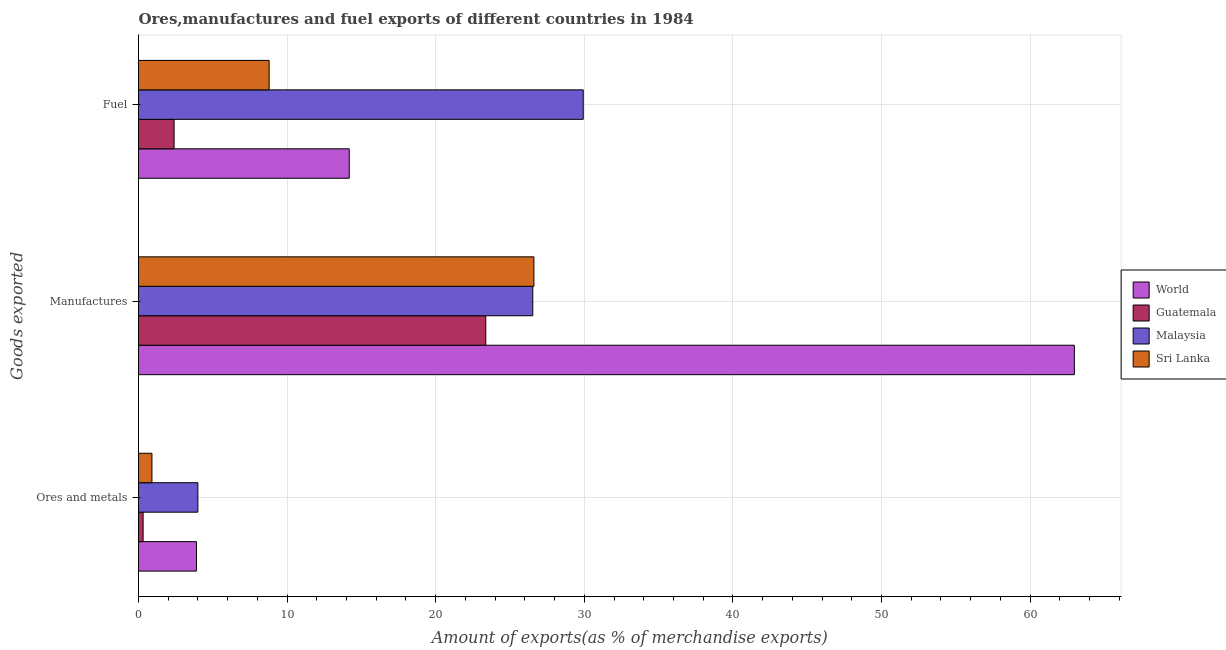How many different coloured bars are there?
Keep it short and to the point. 4. Are the number of bars per tick equal to the number of legend labels?
Your answer should be very brief. Yes. How many bars are there on the 2nd tick from the top?
Your answer should be very brief. 4. What is the label of the 2nd group of bars from the top?
Your answer should be compact. Manufactures. What is the percentage of manufactures exports in World?
Offer a very short reply. 62.98. Across all countries, what is the maximum percentage of fuel exports?
Keep it short and to the point. 29.93. Across all countries, what is the minimum percentage of manufactures exports?
Offer a terse response. 23.37. In which country was the percentage of ores and metals exports maximum?
Make the answer very short. Malaysia. In which country was the percentage of ores and metals exports minimum?
Give a very brief answer. Guatemala. What is the total percentage of ores and metals exports in the graph?
Provide a short and direct response. 9.11. What is the difference between the percentage of ores and metals exports in World and that in Malaysia?
Offer a terse response. -0.1. What is the difference between the percentage of ores and metals exports in Malaysia and the percentage of manufactures exports in Sri Lanka?
Your response must be concise. -22.62. What is the average percentage of ores and metals exports per country?
Ensure brevity in your answer.  2.28. What is the difference between the percentage of ores and metals exports and percentage of manufactures exports in World?
Keep it short and to the point. -59.08. What is the ratio of the percentage of ores and metals exports in Guatemala to that in World?
Provide a succinct answer. 0.08. What is the difference between the highest and the second highest percentage of fuel exports?
Make the answer very short. 15.75. What is the difference between the highest and the lowest percentage of manufactures exports?
Your answer should be compact. 39.61. What does the 1st bar from the top in Ores and metals represents?
Offer a terse response. Sri Lanka. What does the 1st bar from the bottom in Manufactures represents?
Your answer should be compact. World. Is it the case that in every country, the sum of the percentage of ores and metals exports and percentage of manufactures exports is greater than the percentage of fuel exports?
Ensure brevity in your answer.  Yes. Are all the bars in the graph horizontal?
Offer a very short reply. Yes. How many countries are there in the graph?
Provide a succinct answer. 4. Are the values on the major ticks of X-axis written in scientific E-notation?
Make the answer very short. No. How many legend labels are there?
Your response must be concise. 4. What is the title of the graph?
Offer a terse response. Ores,manufactures and fuel exports of different countries in 1984. What is the label or title of the X-axis?
Make the answer very short. Amount of exports(as % of merchandise exports). What is the label or title of the Y-axis?
Your response must be concise. Goods exported. What is the Amount of exports(as % of merchandise exports) of World in Ores and metals?
Offer a terse response. 3.9. What is the Amount of exports(as % of merchandise exports) of Guatemala in Ores and metals?
Make the answer very short. 0.31. What is the Amount of exports(as % of merchandise exports) of Malaysia in Ores and metals?
Offer a very short reply. 3.99. What is the Amount of exports(as % of merchandise exports) in Sri Lanka in Ores and metals?
Your answer should be very brief. 0.9. What is the Amount of exports(as % of merchandise exports) in World in Manufactures?
Keep it short and to the point. 62.98. What is the Amount of exports(as % of merchandise exports) in Guatemala in Manufactures?
Provide a succinct answer. 23.37. What is the Amount of exports(as % of merchandise exports) of Malaysia in Manufactures?
Provide a short and direct response. 26.53. What is the Amount of exports(as % of merchandise exports) in Sri Lanka in Manufactures?
Provide a short and direct response. 26.61. What is the Amount of exports(as % of merchandise exports) in World in Fuel?
Ensure brevity in your answer.  14.18. What is the Amount of exports(as % of merchandise exports) in Guatemala in Fuel?
Offer a very short reply. 2.39. What is the Amount of exports(as % of merchandise exports) in Malaysia in Fuel?
Provide a short and direct response. 29.93. What is the Amount of exports(as % of merchandise exports) of Sri Lanka in Fuel?
Offer a very short reply. 8.79. Across all Goods exported, what is the maximum Amount of exports(as % of merchandise exports) in World?
Give a very brief answer. 62.98. Across all Goods exported, what is the maximum Amount of exports(as % of merchandise exports) of Guatemala?
Your answer should be very brief. 23.37. Across all Goods exported, what is the maximum Amount of exports(as % of merchandise exports) in Malaysia?
Make the answer very short. 29.93. Across all Goods exported, what is the maximum Amount of exports(as % of merchandise exports) of Sri Lanka?
Your answer should be very brief. 26.61. Across all Goods exported, what is the minimum Amount of exports(as % of merchandise exports) in World?
Ensure brevity in your answer.  3.9. Across all Goods exported, what is the minimum Amount of exports(as % of merchandise exports) in Guatemala?
Offer a terse response. 0.31. Across all Goods exported, what is the minimum Amount of exports(as % of merchandise exports) in Malaysia?
Your answer should be compact. 3.99. Across all Goods exported, what is the minimum Amount of exports(as % of merchandise exports) of Sri Lanka?
Offer a terse response. 0.9. What is the total Amount of exports(as % of merchandise exports) of World in the graph?
Your response must be concise. 81.06. What is the total Amount of exports(as % of merchandise exports) in Guatemala in the graph?
Make the answer very short. 26.08. What is the total Amount of exports(as % of merchandise exports) of Malaysia in the graph?
Keep it short and to the point. 60.46. What is the total Amount of exports(as % of merchandise exports) of Sri Lanka in the graph?
Provide a short and direct response. 36.31. What is the difference between the Amount of exports(as % of merchandise exports) of World in Ores and metals and that in Manufactures?
Keep it short and to the point. -59.08. What is the difference between the Amount of exports(as % of merchandise exports) of Guatemala in Ores and metals and that in Manufactures?
Provide a succinct answer. -23.06. What is the difference between the Amount of exports(as % of merchandise exports) of Malaysia in Ores and metals and that in Manufactures?
Make the answer very short. -22.54. What is the difference between the Amount of exports(as % of merchandise exports) in Sri Lanka in Ores and metals and that in Manufactures?
Your answer should be compact. -25.71. What is the difference between the Amount of exports(as % of merchandise exports) of World in Ores and metals and that in Fuel?
Ensure brevity in your answer.  -10.28. What is the difference between the Amount of exports(as % of merchandise exports) in Guatemala in Ores and metals and that in Fuel?
Ensure brevity in your answer.  -2.09. What is the difference between the Amount of exports(as % of merchandise exports) of Malaysia in Ores and metals and that in Fuel?
Keep it short and to the point. -25.93. What is the difference between the Amount of exports(as % of merchandise exports) of Sri Lanka in Ores and metals and that in Fuel?
Provide a short and direct response. -7.89. What is the difference between the Amount of exports(as % of merchandise exports) of World in Manufactures and that in Fuel?
Ensure brevity in your answer.  48.8. What is the difference between the Amount of exports(as % of merchandise exports) of Guatemala in Manufactures and that in Fuel?
Offer a very short reply. 20.98. What is the difference between the Amount of exports(as % of merchandise exports) of Malaysia in Manufactures and that in Fuel?
Give a very brief answer. -3.4. What is the difference between the Amount of exports(as % of merchandise exports) of Sri Lanka in Manufactures and that in Fuel?
Give a very brief answer. 17.82. What is the difference between the Amount of exports(as % of merchandise exports) in World in Ores and metals and the Amount of exports(as % of merchandise exports) in Guatemala in Manufactures?
Your response must be concise. -19.47. What is the difference between the Amount of exports(as % of merchandise exports) in World in Ores and metals and the Amount of exports(as % of merchandise exports) in Malaysia in Manufactures?
Provide a succinct answer. -22.63. What is the difference between the Amount of exports(as % of merchandise exports) of World in Ores and metals and the Amount of exports(as % of merchandise exports) of Sri Lanka in Manufactures?
Make the answer very short. -22.71. What is the difference between the Amount of exports(as % of merchandise exports) of Guatemala in Ores and metals and the Amount of exports(as % of merchandise exports) of Malaysia in Manufactures?
Keep it short and to the point. -26.22. What is the difference between the Amount of exports(as % of merchandise exports) of Guatemala in Ores and metals and the Amount of exports(as % of merchandise exports) of Sri Lanka in Manufactures?
Provide a succinct answer. -26.3. What is the difference between the Amount of exports(as % of merchandise exports) of Malaysia in Ores and metals and the Amount of exports(as % of merchandise exports) of Sri Lanka in Manufactures?
Provide a short and direct response. -22.62. What is the difference between the Amount of exports(as % of merchandise exports) of World in Ores and metals and the Amount of exports(as % of merchandise exports) of Guatemala in Fuel?
Your answer should be compact. 1.5. What is the difference between the Amount of exports(as % of merchandise exports) in World in Ores and metals and the Amount of exports(as % of merchandise exports) in Malaysia in Fuel?
Make the answer very short. -26.03. What is the difference between the Amount of exports(as % of merchandise exports) in World in Ores and metals and the Amount of exports(as % of merchandise exports) in Sri Lanka in Fuel?
Give a very brief answer. -4.89. What is the difference between the Amount of exports(as % of merchandise exports) of Guatemala in Ores and metals and the Amount of exports(as % of merchandise exports) of Malaysia in Fuel?
Your answer should be very brief. -29.62. What is the difference between the Amount of exports(as % of merchandise exports) in Guatemala in Ores and metals and the Amount of exports(as % of merchandise exports) in Sri Lanka in Fuel?
Offer a very short reply. -8.48. What is the difference between the Amount of exports(as % of merchandise exports) of Malaysia in Ores and metals and the Amount of exports(as % of merchandise exports) of Sri Lanka in Fuel?
Give a very brief answer. -4.8. What is the difference between the Amount of exports(as % of merchandise exports) of World in Manufactures and the Amount of exports(as % of merchandise exports) of Guatemala in Fuel?
Your answer should be compact. 60.59. What is the difference between the Amount of exports(as % of merchandise exports) of World in Manufactures and the Amount of exports(as % of merchandise exports) of Malaysia in Fuel?
Ensure brevity in your answer.  33.05. What is the difference between the Amount of exports(as % of merchandise exports) in World in Manufactures and the Amount of exports(as % of merchandise exports) in Sri Lanka in Fuel?
Offer a very short reply. 54.19. What is the difference between the Amount of exports(as % of merchandise exports) in Guatemala in Manufactures and the Amount of exports(as % of merchandise exports) in Malaysia in Fuel?
Keep it short and to the point. -6.56. What is the difference between the Amount of exports(as % of merchandise exports) in Guatemala in Manufactures and the Amount of exports(as % of merchandise exports) in Sri Lanka in Fuel?
Offer a terse response. 14.58. What is the difference between the Amount of exports(as % of merchandise exports) of Malaysia in Manufactures and the Amount of exports(as % of merchandise exports) of Sri Lanka in Fuel?
Make the answer very short. 17.74. What is the average Amount of exports(as % of merchandise exports) in World per Goods exported?
Your answer should be compact. 27.02. What is the average Amount of exports(as % of merchandise exports) of Guatemala per Goods exported?
Make the answer very short. 8.69. What is the average Amount of exports(as % of merchandise exports) of Malaysia per Goods exported?
Ensure brevity in your answer.  20.15. What is the average Amount of exports(as % of merchandise exports) of Sri Lanka per Goods exported?
Provide a short and direct response. 12.1. What is the difference between the Amount of exports(as % of merchandise exports) of World and Amount of exports(as % of merchandise exports) of Guatemala in Ores and metals?
Ensure brevity in your answer.  3.59. What is the difference between the Amount of exports(as % of merchandise exports) in World and Amount of exports(as % of merchandise exports) in Malaysia in Ores and metals?
Your response must be concise. -0.1. What is the difference between the Amount of exports(as % of merchandise exports) of World and Amount of exports(as % of merchandise exports) of Sri Lanka in Ores and metals?
Your answer should be very brief. 3. What is the difference between the Amount of exports(as % of merchandise exports) in Guatemala and Amount of exports(as % of merchandise exports) in Malaysia in Ores and metals?
Give a very brief answer. -3.68. What is the difference between the Amount of exports(as % of merchandise exports) of Guatemala and Amount of exports(as % of merchandise exports) of Sri Lanka in Ores and metals?
Give a very brief answer. -0.59. What is the difference between the Amount of exports(as % of merchandise exports) in Malaysia and Amount of exports(as % of merchandise exports) in Sri Lanka in Ores and metals?
Offer a very short reply. 3.09. What is the difference between the Amount of exports(as % of merchandise exports) of World and Amount of exports(as % of merchandise exports) of Guatemala in Manufactures?
Offer a terse response. 39.61. What is the difference between the Amount of exports(as % of merchandise exports) in World and Amount of exports(as % of merchandise exports) in Malaysia in Manufactures?
Ensure brevity in your answer.  36.45. What is the difference between the Amount of exports(as % of merchandise exports) of World and Amount of exports(as % of merchandise exports) of Sri Lanka in Manufactures?
Your response must be concise. 36.37. What is the difference between the Amount of exports(as % of merchandise exports) in Guatemala and Amount of exports(as % of merchandise exports) in Malaysia in Manufactures?
Provide a short and direct response. -3.16. What is the difference between the Amount of exports(as % of merchandise exports) of Guatemala and Amount of exports(as % of merchandise exports) of Sri Lanka in Manufactures?
Offer a very short reply. -3.24. What is the difference between the Amount of exports(as % of merchandise exports) of Malaysia and Amount of exports(as % of merchandise exports) of Sri Lanka in Manufactures?
Provide a succinct answer. -0.08. What is the difference between the Amount of exports(as % of merchandise exports) of World and Amount of exports(as % of merchandise exports) of Guatemala in Fuel?
Offer a very short reply. 11.79. What is the difference between the Amount of exports(as % of merchandise exports) in World and Amount of exports(as % of merchandise exports) in Malaysia in Fuel?
Your response must be concise. -15.75. What is the difference between the Amount of exports(as % of merchandise exports) of World and Amount of exports(as % of merchandise exports) of Sri Lanka in Fuel?
Your answer should be very brief. 5.39. What is the difference between the Amount of exports(as % of merchandise exports) in Guatemala and Amount of exports(as % of merchandise exports) in Malaysia in Fuel?
Provide a succinct answer. -27.53. What is the difference between the Amount of exports(as % of merchandise exports) in Guatemala and Amount of exports(as % of merchandise exports) in Sri Lanka in Fuel?
Your answer should be very brief. -6.4. What is the difference between the Amount of exports(as % of merchandise exports) of Malaysia and Amount of exports(as % of merchandise exports) of Sri Lanka in Fuel?
Your answer should be compact. 21.14. What is the ratio of the Amount of exports(as % of merchandise exports) in World in Ores and metals to that in Manufactures?
Make the answer very short. 0.06. What is the ratio of the Amount of exports(as % of merchandise exports) of Guatemala in Ores and metals to that in Manufactures?
Make the answer very short. 0.01. What is the ratio of the Amount of exports(as % of merchandise exports) in Malaysia in Ores and metals to that in Manufactures?
Offer a very short reply. 0.15. What is the ratio of the Amount of exports(as % of merchandise exports) in Sri Lanka in Ores and metals to that in Manufactures?
Provide a succinct answer. 0.03. What is the ratio of the Amount of exports(as % of merchandise exports) in World in Ores and metals to that in Fuel?
Ensure brevity in your answer.  0.28. What is the ratio of the Amount of exports(as % of merchandise exports) in Guatemala in Ores and metals to that in Fuel?
Ensure brevity in your answer.  0.13. What is the ratio of the Amount of exports(as % of merchandise exports) in Malaysia in Ores and metals to that in Fuel?
Your response must be concise. 0.13. What is the ratio of the Amount of exports(as % of merchandise exports) in Sri Lanka in Ores and metals to that in Fuel?
Your answer should be very brief. 0.1. What is the ratio of the Amount of exports(as % of merchandise exports) of World in Manufactures to that in Fuel?
Give a very brief answer. 4.44. What is the ratio of the Amount of exports(as % of merchandise exports) in Guatemala in Manufactures to that in Fuel?
Your answer should be compact. 9.76. What is the ratio of the Amount of exports(as % of merchandise exports) in Malaysia in Manufactures to that in Fuel?
Ensure brevity in your answer.  0.89. What is the ratio of the Amount of exports(as % of merchandise exports) of Sri Lanka in Manufactures to that in Fuel?
Your response must be concise. 3.03. What is the difference between the highest and the second highest Amount of exports(as % of merchandise exports) of World?
Your response must be concise. 48.8. What is the difference between the highest and the second highest Amount of exports(as % of merchandise exports) in Guatemala?
Your response must be concise. 20.98. What is the difference between the highest and the second highest Amount of exports(as % of merchandise exports) of Malaysia?
Keep it short and to the point. 3.4. What is the difference between the highest and the second highest Amount of exports(as % of merchandise exports) of Sri Lanka?
Keep it short and to the point. 17.82. What is the difference between the highest and the lowest Amount of exports(as % of merchandise exports) in World?
Your answer should be compact. 59.08. What is the difference between the highest and the lowest Amount of exports(as % of merchandise exports) in Guatemala?
Provide a short and direct response. 23.06. What is the difference between the highest and the lowest Amount of exports(as % of merchandise exports) in Malaysia?
Make the answer very short. 25.93. What is the difference between the highest and the lowest Amount of exports(as % of merchandise exports) of Sri Lanka?
Offer a very short reply. 25.71. 